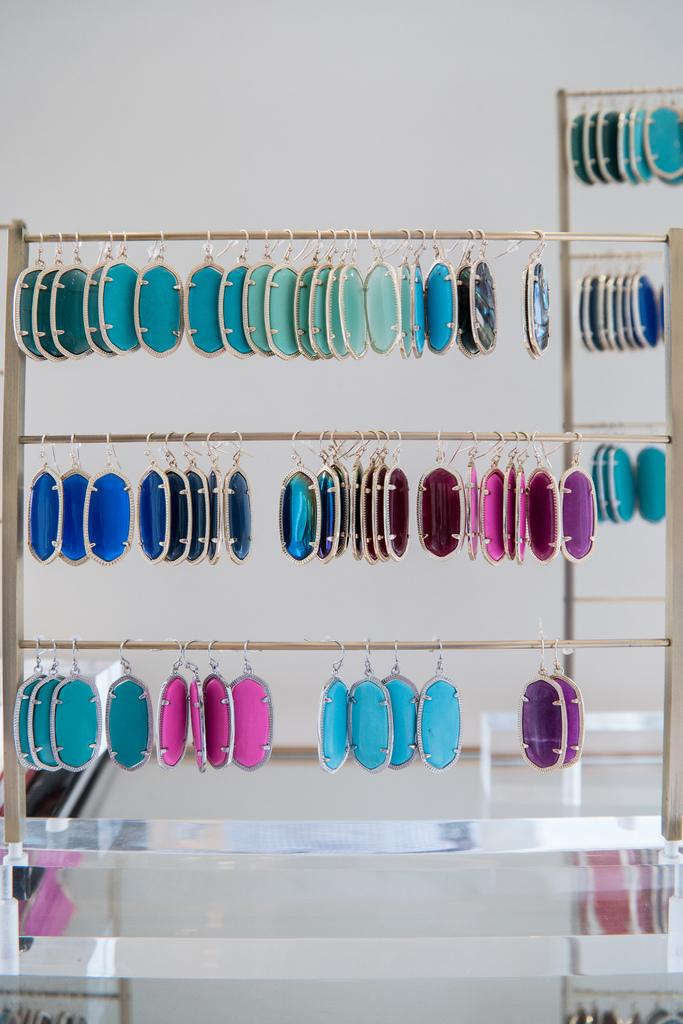What is the main object in the image? There is a stand in the image. What is placed on the stand? There are things on the stand. Can you describe the appearance of the items on the stand? The things on the stand have different colors. What story is being told by the objects on the stand? There is no story being told by the objects on the stand in the image. What type of party is being depicted in the image? There is no party depicted in the image; it only shows a stand with items of different colors. 